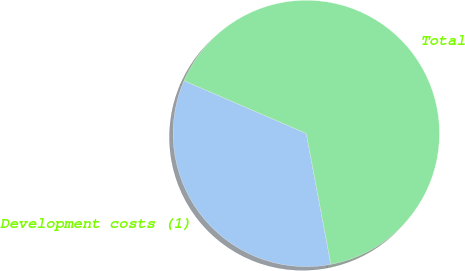<chart> <loc_0><loc_0><loc_500><loc_500><pie_chart><fcel>Development costs (1)<fcel>Total<nl><fcel>34.44%<fcel>65.56%<nl></chart> 